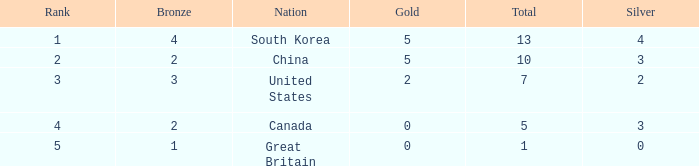What is the lowest Rank, when Nation is Great Britain, and when Bronze is less than 1? None. 